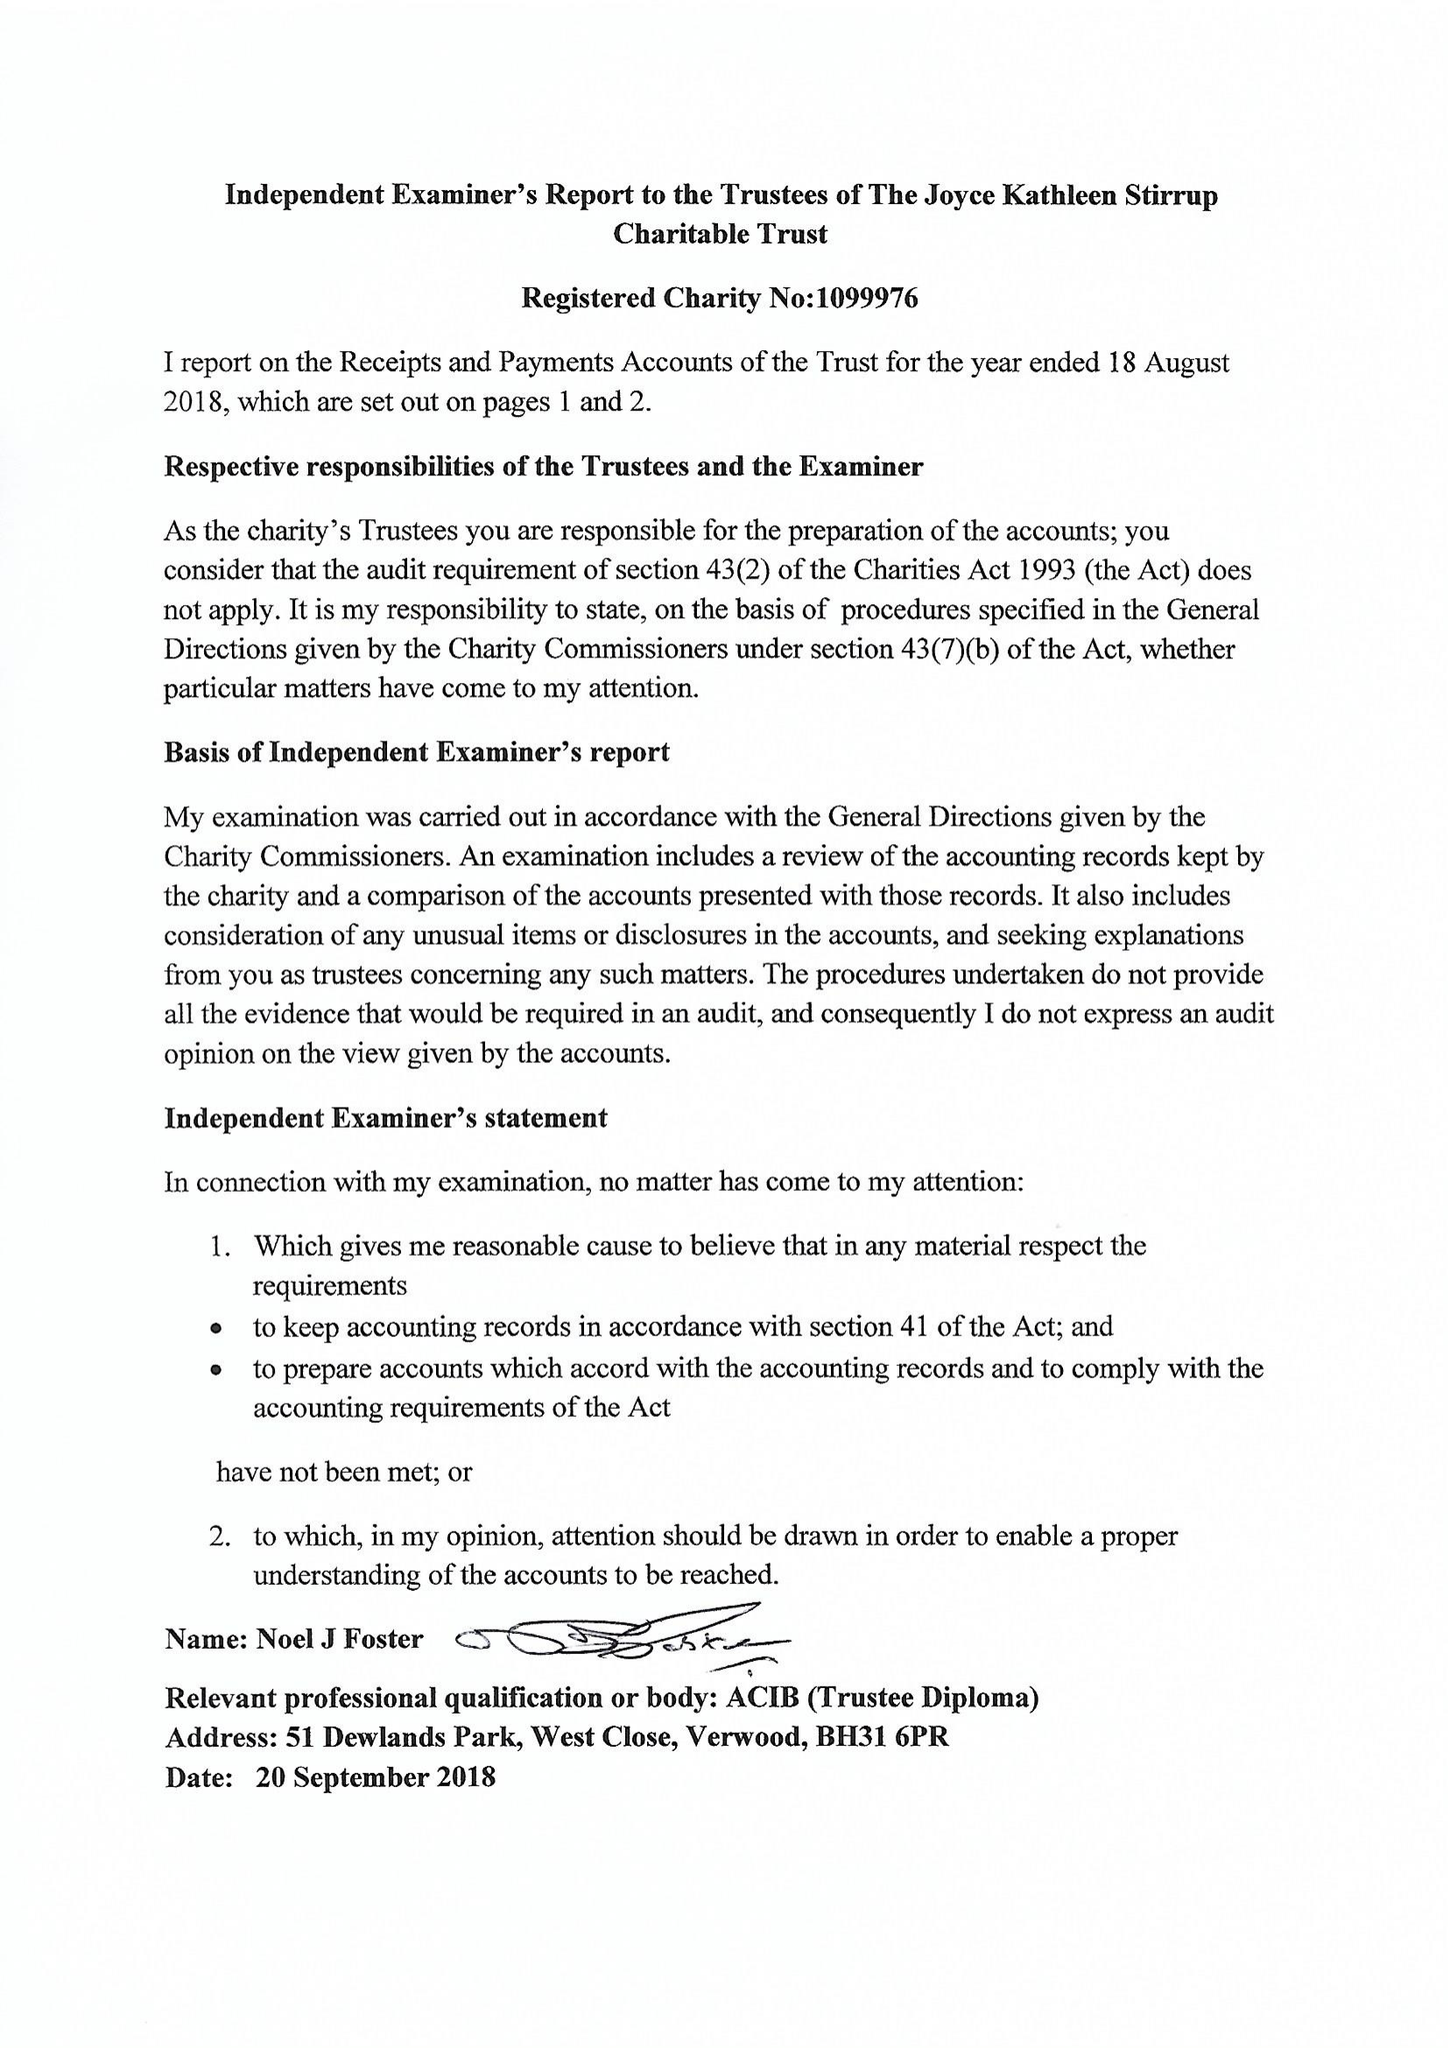What is the value for the charity_name?
Answer the question using a single word or phrase. The Miss J K Stirrup Charity Trust 